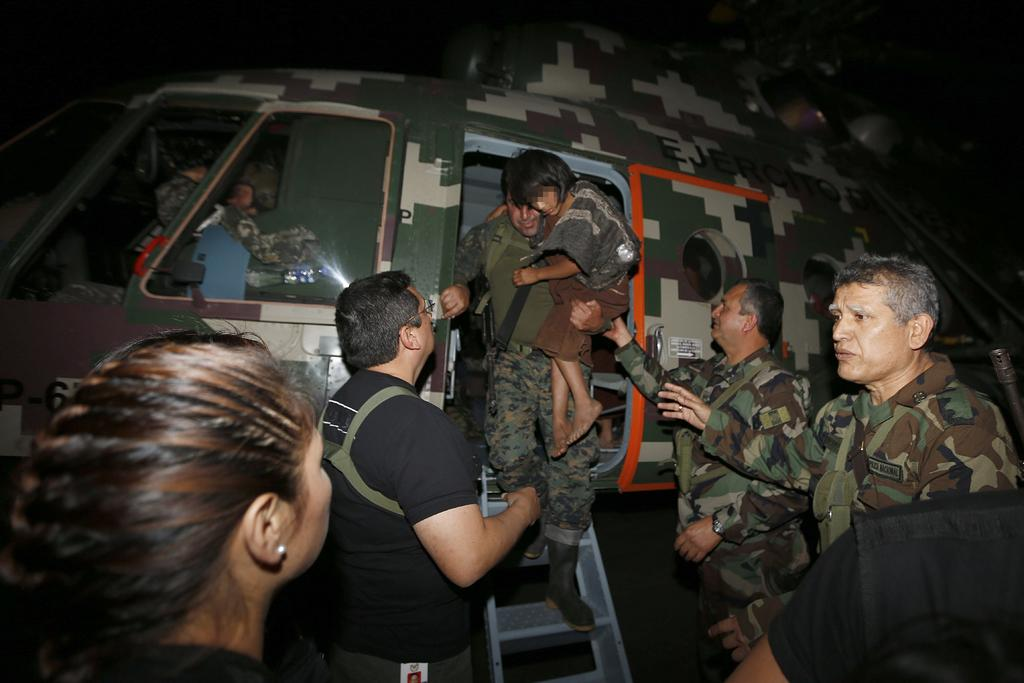What is the main subject of the image? There is a chopper in the image. How many people are in the image? There are five members in the image. Can you describe the age of one of the members? One of the members is a child. What is the gender distribution among the members? Four of the members are men, and one is a woman. What can be said about the lighting in the image? The background of the image is dark. What type of stew is being prepared by the members in the image? There is no indication of any stew being prepared in the image; the focus is on the chopper and the people. What emotion might the woman be feeling in the image? The image does not convey any specific emotions, so it is impossible to determine how the woman might be feeling. 